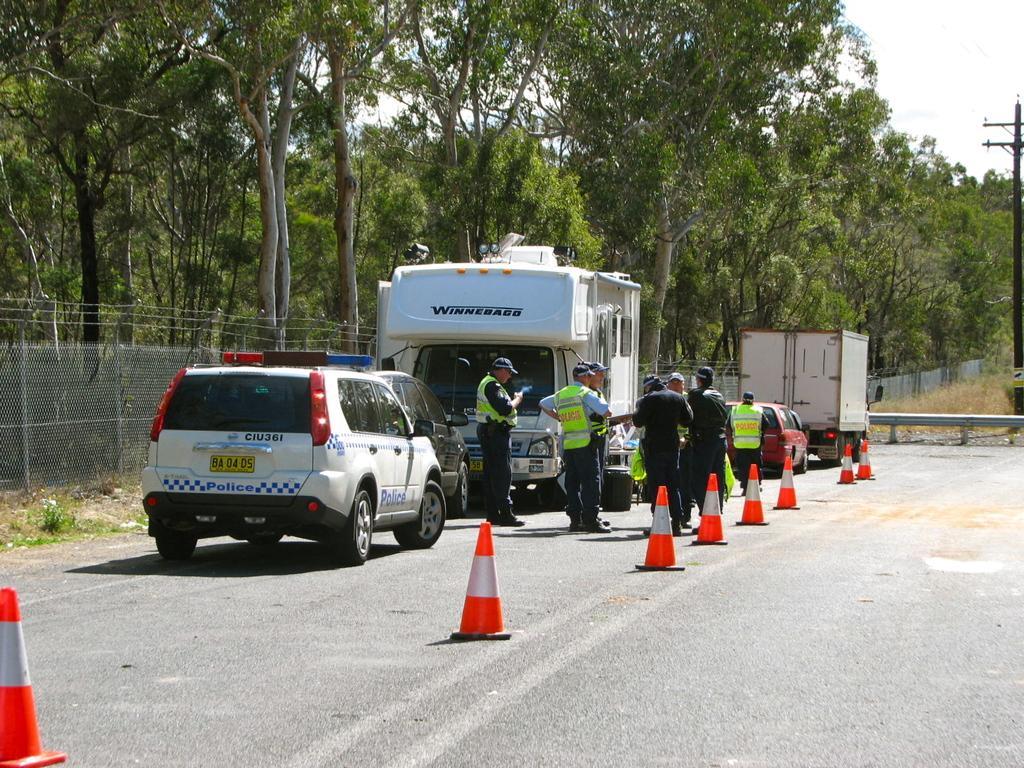Please provide a concise description of this image. In this picture we can see the sky, trees, a current pole. We can see the vehicles, people and traffic cones on the road. We can see dried grass, railing and the fence. 